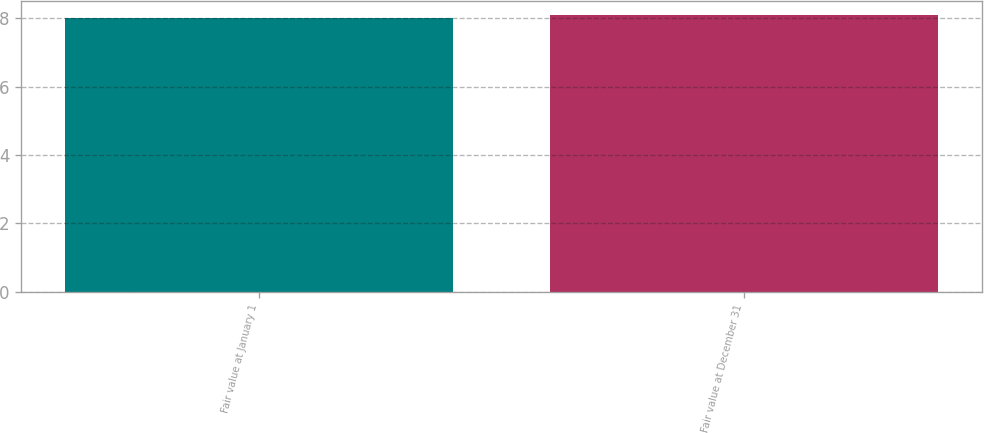<chart> <loc_0><loc_0><loc_500><loc_500><bar_chart><fcel>Fair value at January 1<fcel>Fair value at December 31<nl><fcel>8<fcel>8.1<nl></chart> 